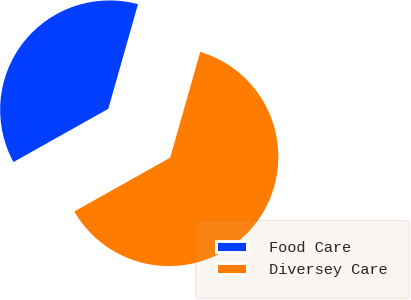Convert chart to OTSL. <chart><loc_0><loc_0><loc_500><loc_500><pie_chart><fcel>Food Care<fcel>Diversey Care<nl><fcel>37.54%<fcel>62.46%<nl></chart> 